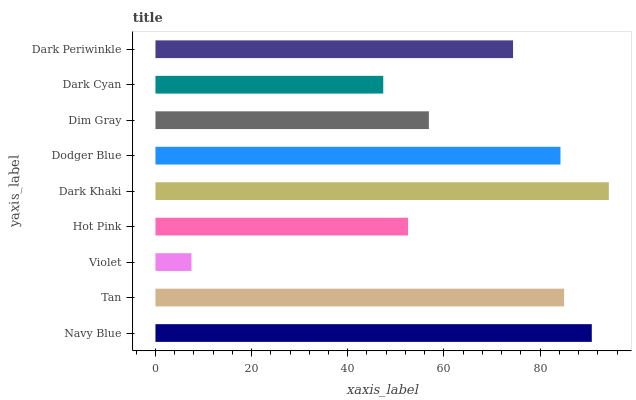Is Violet the minimum?
Answer yes or no. Yes. Is Dark Khaki the maximum?
Answer yes or no. Yes. Is Tan the minimum?
Answer yes or no. No. Is Tan the maximum?
Answer yes or no. No. Is Navy Blue greater than Tan?
Answer yes or no. Yes. Is Tan less than Navy Blue?
Answer yes or no. Yes. Is Tan greater than Navy Blue?
Answer yes or no. No. Is Navy Blue less than Tan?
Answer yes or no. No. Is Dark Periwinkle the high median?
Answer yes or no. Yes. Is Dark Periwinkle the low median?
Answer yes or no. Yes. Is Violet the high median?
Answer yes or no. No. Is Dim Gray the low median?
Answer yes or no. No. 